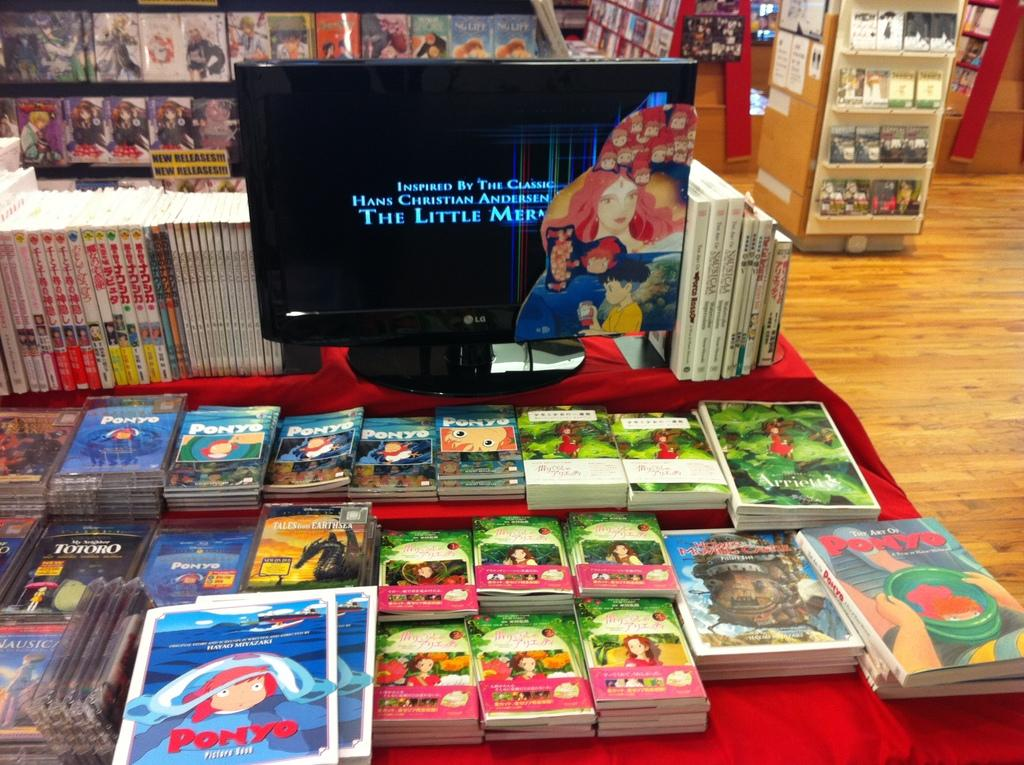<image>
Render a clear and concise summary of the photo. A television that says The Little Mermaid is in front of a number of children books on display. 